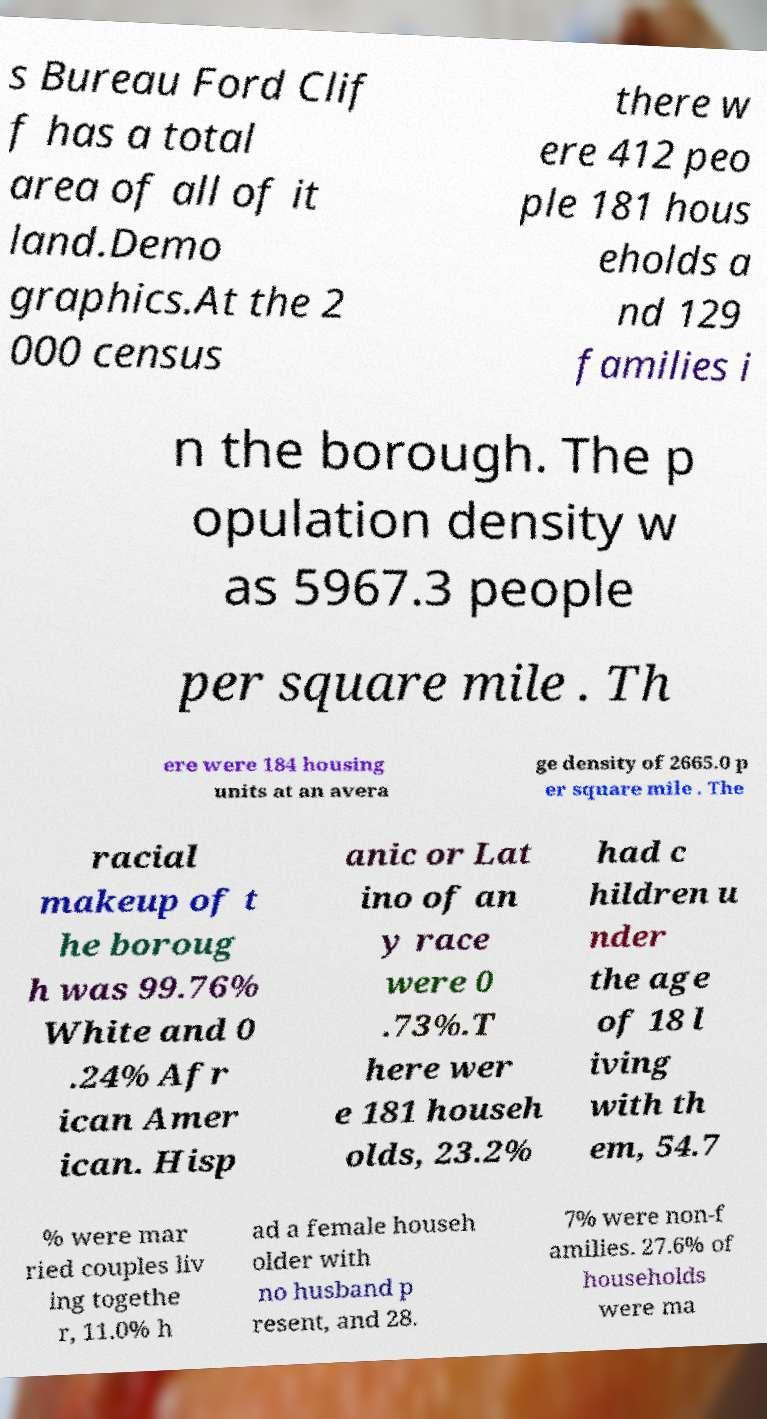Could you extract and type out the text from this image? s Bureau Ford Clif f has a total area of all of it land.Demo graphics.At the 2 000 census there w ere 412 peo ple 181 hous eholds a nd 129 families i n the borough. The p opulation density w as 5967.3 people per square mile . Th ere were 184 housing units at an avera ge density of 2665.0 p er square mile . The racial makeup of t he boroug h was 99.76% White and 0 .24% Afr ican Amer ican. Hisp anic or Lat ino of an y race were 0 .73%.T here wer e 181 househ olds, 23.2% had c hildren u nder the age of 18 l iving with th em, 54.7 % were mar ried couples liv ing togethe r, 11.0% h ad a female househ older with no husband p resent, and 28. 7% were non-f amilies. 27.6% of households were ma 